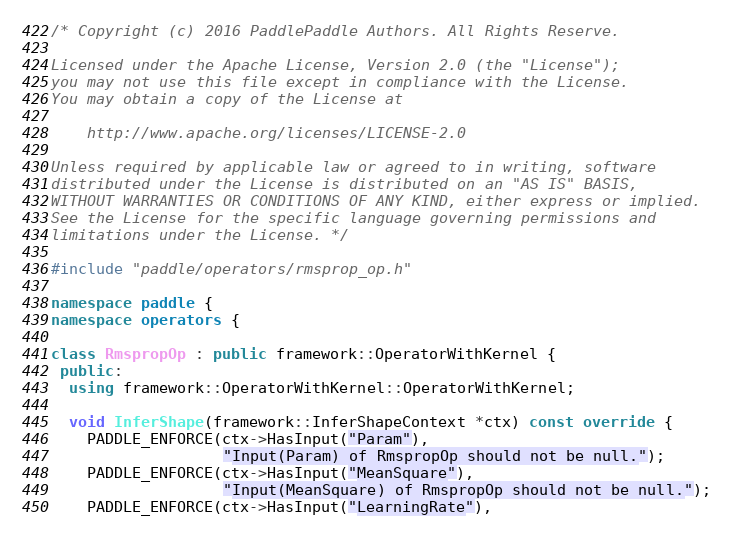Convert code to text. <code><loc_0><loc_0><loc_500><loc_500><_C++_>/* Copyright (c) 2016 PaddlePaddle Authors. All Rights Reserve.

Licensed under the Apache License, Version 2.0 (the "License");
you may not use this file except in compliance with the License.
You may obtain a copy of the License at

    http://www.apache.org/licenses/LICENSE-2.0

Unless required by applicable law or agreed to in writing, software
distributed under the License is distributed on an "AS IS" BASIS,
WITHOUT WARRANTIES OR CONDITIONS OF ANY KIND, either express or implied.
See the License for the specific language governing permissions and
limitations under the License. */

#include "paddle/operators/rmsprop_op.h"

namespace paddle {
namespace operators {

class RmspropOp : public framework::OperatorWithKernel {
 public:
  using framework::OperatorWithKernel::OperatorWithKernel;

  void InferShape(framework::InferShapeContext *ctx) const override {
    PADDLE_ENFORCE(ctx->HasInput("Param"),
                   "Input(Param) of RmspropOp should not be null.");
    PADDLE_ENFORCE(ctx->HasInput("MeanSquare"),
                   "Input(MeanSquare) of RmspropOp should not be null.");
    PADDLE_ENFORCE(ctx->HasInput("LearningRate"),</code> 